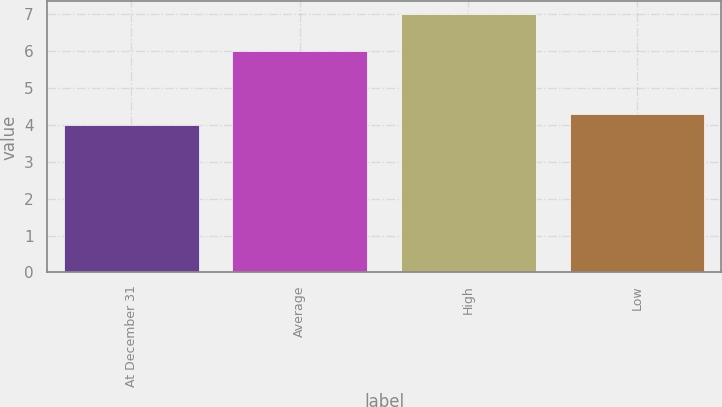Convert chart. <chart><loc_0><loc_0><loc_500><loc_500><bar_chart><fcel>At December 31<fcel>Average<fcel>High<fcel>Low<nl><fcel>4<fcel>6<fcel>7<fcel>4.3<nl></chart> 